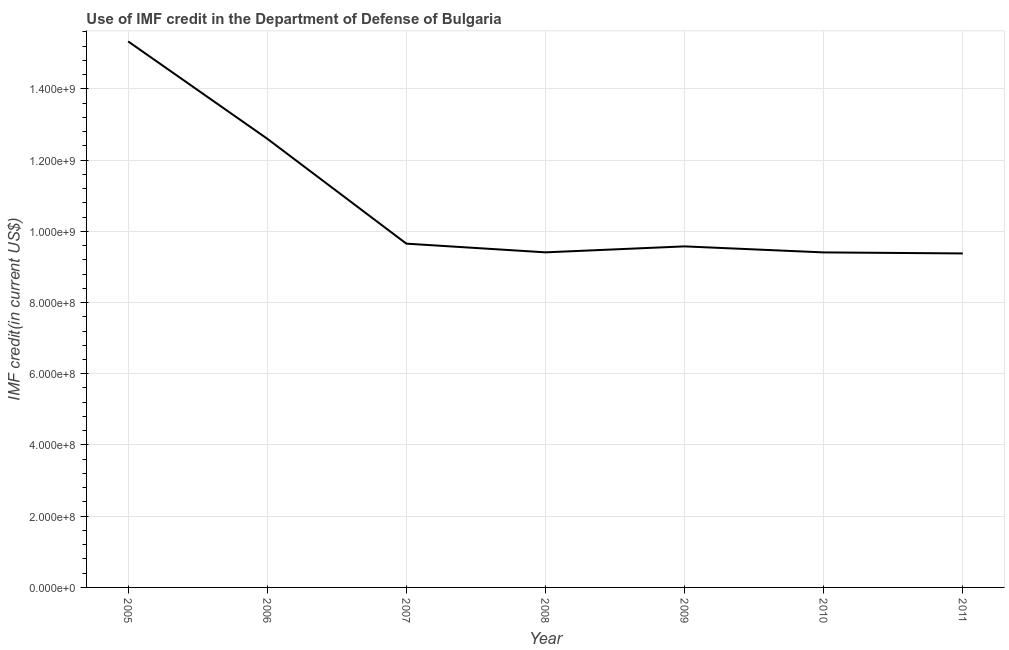What is the use of imf credit in dod in 2007?
Give a very brief answer. 9.65e+08. Across all years, what is the maximum use of imf credit in dod?
Keep it short and to the point. 1.53e+09. Across all years, what is the minimum use of imf credit in dod?
Your response must be concise. 9.38e+08. In which year was the use of imf credit in dod maximum?
Offer a terse response. 2005. What is the sum of the use of imf credit in dod?
Make the answer very short. 7.54e+09. What is the difference between the use of imf credit in dod in 2005 and 2008?
Provide a short and direct response. 5.92e+08. What is the average use of imf credit in dod per year?
Ensure brevity in your answer.  1.08e+09. What is the median use of imf credit in dod?
Keep it short and to the point. 9.58e+08. Do a majority of the years between 2009 and 2005 (inclusive) have use of imf credit in dod greater than 1120000000 US$?
Your answer should be compact. Yes. What is the ratio of the use of imf credit in dod in 2008 to that in 2011?
Offer a very short reply. 1. Is the difference between the use of imf credit in dod in 2006 and 2008 greater than the difference between any two years?
Your answer should be very brief. No. What is the difference between the highest and the second highest use of imf credit in dod?
Your response must be concise. 2.73e+08. Is the sum of the use of imf credit in dod in 2006 and 2010 greater than the maximum use of imf credit in dod across all years?
Give a very brief answer. Yes. What is the difference between the highest and the lowest use of imf credit in dod?
Provide a succinct answer. 5.95e+08. In how many years, is the use of imf credit in dod greater than the average use of imf credit in dod taken over all years?
Offer a very short reply. 2. Does the use of imf credit in dod monotonically increase over the years?
Offer a very short reply. No. How many lines are there?
Ensure brevity in your answer.  1. Does the graph contain any zero values?
Make the answer very short. No. What is the title of the graph?
Keep it short and to the point. Use of IMF credit in the Department of Defense of Bulgaria. What is the label or title of the X-axis?
Give a very brief answer. Year. What is the label or title of the Y-axis?
Give a very brief answer. IMF credit(in current US$). What is the IMF credit(in current US$) in 2005?
Provide a succinct answer. 1.53e+09. What is the IMF credit(in current US$) of 2006?
Ensure brevity in your answer.  1.26e+09. What is the IMF credit(in current US$) of 2007?
Provide a succinct answer. 9.65e+08. What is the IMF credit(in current US$) in 2008?
Your answer should be very brief. 9.41e+08. What is the IMF credit(in current US$) in 2009?
Your answer should be very brief. 9.58e+08. What is the IMF credit(in current US$) in 2010?
Provide a short and direct response. 9.41e+08. What is the IMF credit(in current US$) in 2011?
Provide a succinct answer. 9.38e+08. What is the difference between the IMF credit(in current US$) in 2005 and 2006?
Provide a short and direct response. 2.73e+08. What is the difference between the IMF credit(in current US$) in 2005 and 2007?
Keep it short and to the point. 5.68e+08. What is the difference between the IMF credit(in current US$) in 2005 and 2008?
Provide a short and direct response. 5.92e+08. What is the difference between the IMF credit(in current US$) in 2005 and 2009?
Give a very brief answer. 5.76e+08. What is the difference between the IMF credit(in current US$) in 2005 and 2010?
Provide a succinct answer. 5.92e+08. What is the difference between the IMF credit(in current US$) in 2005 and 2011?
Your response must be concise. 5.95e+08. What is the difference between the IMF credit(in current US$) in 2006 and 2007?
Offer a very short reply. 2.95e+08. What is the difference between the IMF credit(in current US$) in 2006 and 2008?
Provide a succinct answer. 3.19e+08. What is the difference between the IMF credit(in current US$) in 2006 and 2009?
Provide a succinct answer. 3.02e+08. What is the difference between the IMF credit(in current US$) in 2006 and 2010?
Provide a succinct answer. 3.19e+08. What is the difference between the IMF credit(in current US$) in 2006 and 2011?
Your response must be concise. 3.22e+08. What is the difference between the IMF credit(in current US$) in 2007 and 2008?
Offer a terse response. 2.44e+07. What is the difference between the IMF credit(in current US$) in 2007 and 2009?
Provide a short and direct response. 7.67e+06. What is the difference between the IMF credit(in current US$) in 2007 and 2010?
Your answer should be compact. 2.46e+07. What is the difference between the IMF credit(in current US$) in 2007 and 2011?
Make the answer very short. 2.75e+07. What is the difference between the IMF credit(in current US$) in 2008 and 2009?
Your response must be concise. -1.68e+07. What is the difference between the IMF credit(in current US$) in 2008 and 2010?
Give a very brief answer. 1.46e+05. What is the difference between the IMF credit(in current US$) in 2008 and 2011?
Provide a succinct answer. 3.05e+06. What is the difference between the IMF credit(in current US$) in 2009 and 2010?
Your response must be concise. 1.69e+07. What is the difference between the IMF credit(in current US$) in 2009 and 2011?
Your answer should be compact. 1.98e+07. What is the difference between the IMF credit(in current US$) in 2010 and 2011?
Offer a very short reply. 2.91e+06. What is the ratio of the IMF credit(in current US$) in 2005 to that in 2006?
Your answer should be compact. 1.22. What is the ratio of the IMF credit(in current US$) in 2005 to that in 2007?
Your answer should be very brief. 1.59. What is the ratio of the IMF credit(in current US$) in 2005 to that in 2008?
Make the answer very short. 1.63. What is the ratio of the IMF credit(in current US$) in 2005 to that in 2009?
Provide a short and direct response. 1.6. What is the ratio of the IMF credit(in current US$) in 2005 to that in 2010?
Your answer should be very brief. 1.63. What is the ratio of the IMF credit(in current US$) in 2005 to that in 2011?
Your answer should be very brief. 1.64. What is the ratio of the IMF credit(in current US$) in 2006 to that in 2007?
Your answer should be very brief. 1.3. What is the ratio of the IMF credit(in current US$) in 2006 to that in 2008?
Provide a short and direct response. 1.34. What is the ratio of the IMF credit(in current US$) in 2006 to that in 2009?
Keep it short and to the point. 1.32. What is the ratio of the IMF credit(in current US$) in 2006 to that in 2010?
Provide a succinct answer. 1.34. What is the ratio of the IMF credit(in current US$) in 2006 to that in 2011?
Your answer should be compact. 1.34. What is the ratio of the IMF credit(in current US$) in 2007 to that in 2008?
Offer a very short reply. 1.03. What is the ratio of the IMF credit(in current US$) in 2007 to that in 2009?
Ensure brevity in your answer.  1.01. What is the ratio of the IMF credit(in current US$) in 2007 to that in 2010?
Provide a succinct answer. 1.03. What is the ratio of the IMF credit(in current US$) in 2007 to that in 2011?
Your answer should be compact. 1.03. What is the ratio of the IMF credit(in current US$) in 2008 to that in 2010?
Provide a short and direct response. 1. What is the ratio of the IMF credit(in current US$) in 2008 to that in 2011?
Ensure brevity in your answer.  1. What is the ratio of the IMF credit(in current US$) in 2009 to that in 2010?
Offer a terse response. 1.02. 